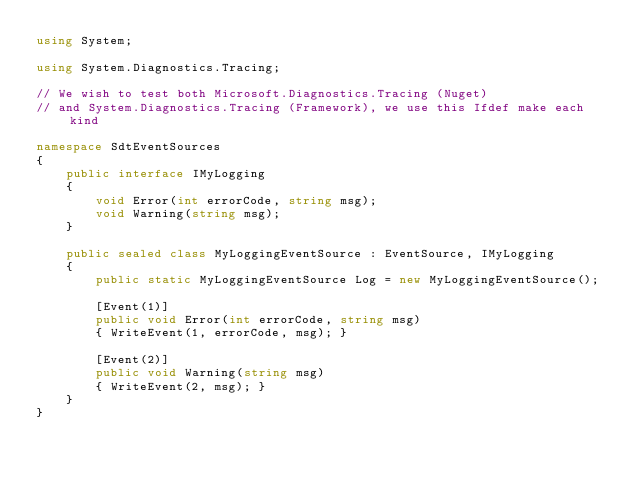Convert code to text. <code><loc_0><loc_0><loc_500><loc_500><_C#_>using System;

using System.Diagnostics.Tracing;

// We wish to test both Microsoft.Diagnostics.Tracing (Nuget)
// and System.Diagnostics.Tracing (Framework), we use this Ifdef make each kind 

namespace SdtEventSources
{
    public interface IMyLogging
    {
        void Error(int errorCode, string msg);
        void Warning(string msg);
    }

    public sealed class MyLoggingEventSource : EventSource, IMyLogging
    {
        public static MyLoggingEventSource Log = new MyLoggingEventSource();

        [Event(1)]
        public void Error(int errorCode, string msg)
        { WriteEvent(1, errorCode, msg); }

        [Event(2)]
        public void Warning(string msg)
        { WriteEvent(2, msg); }
    }
}
</code> 